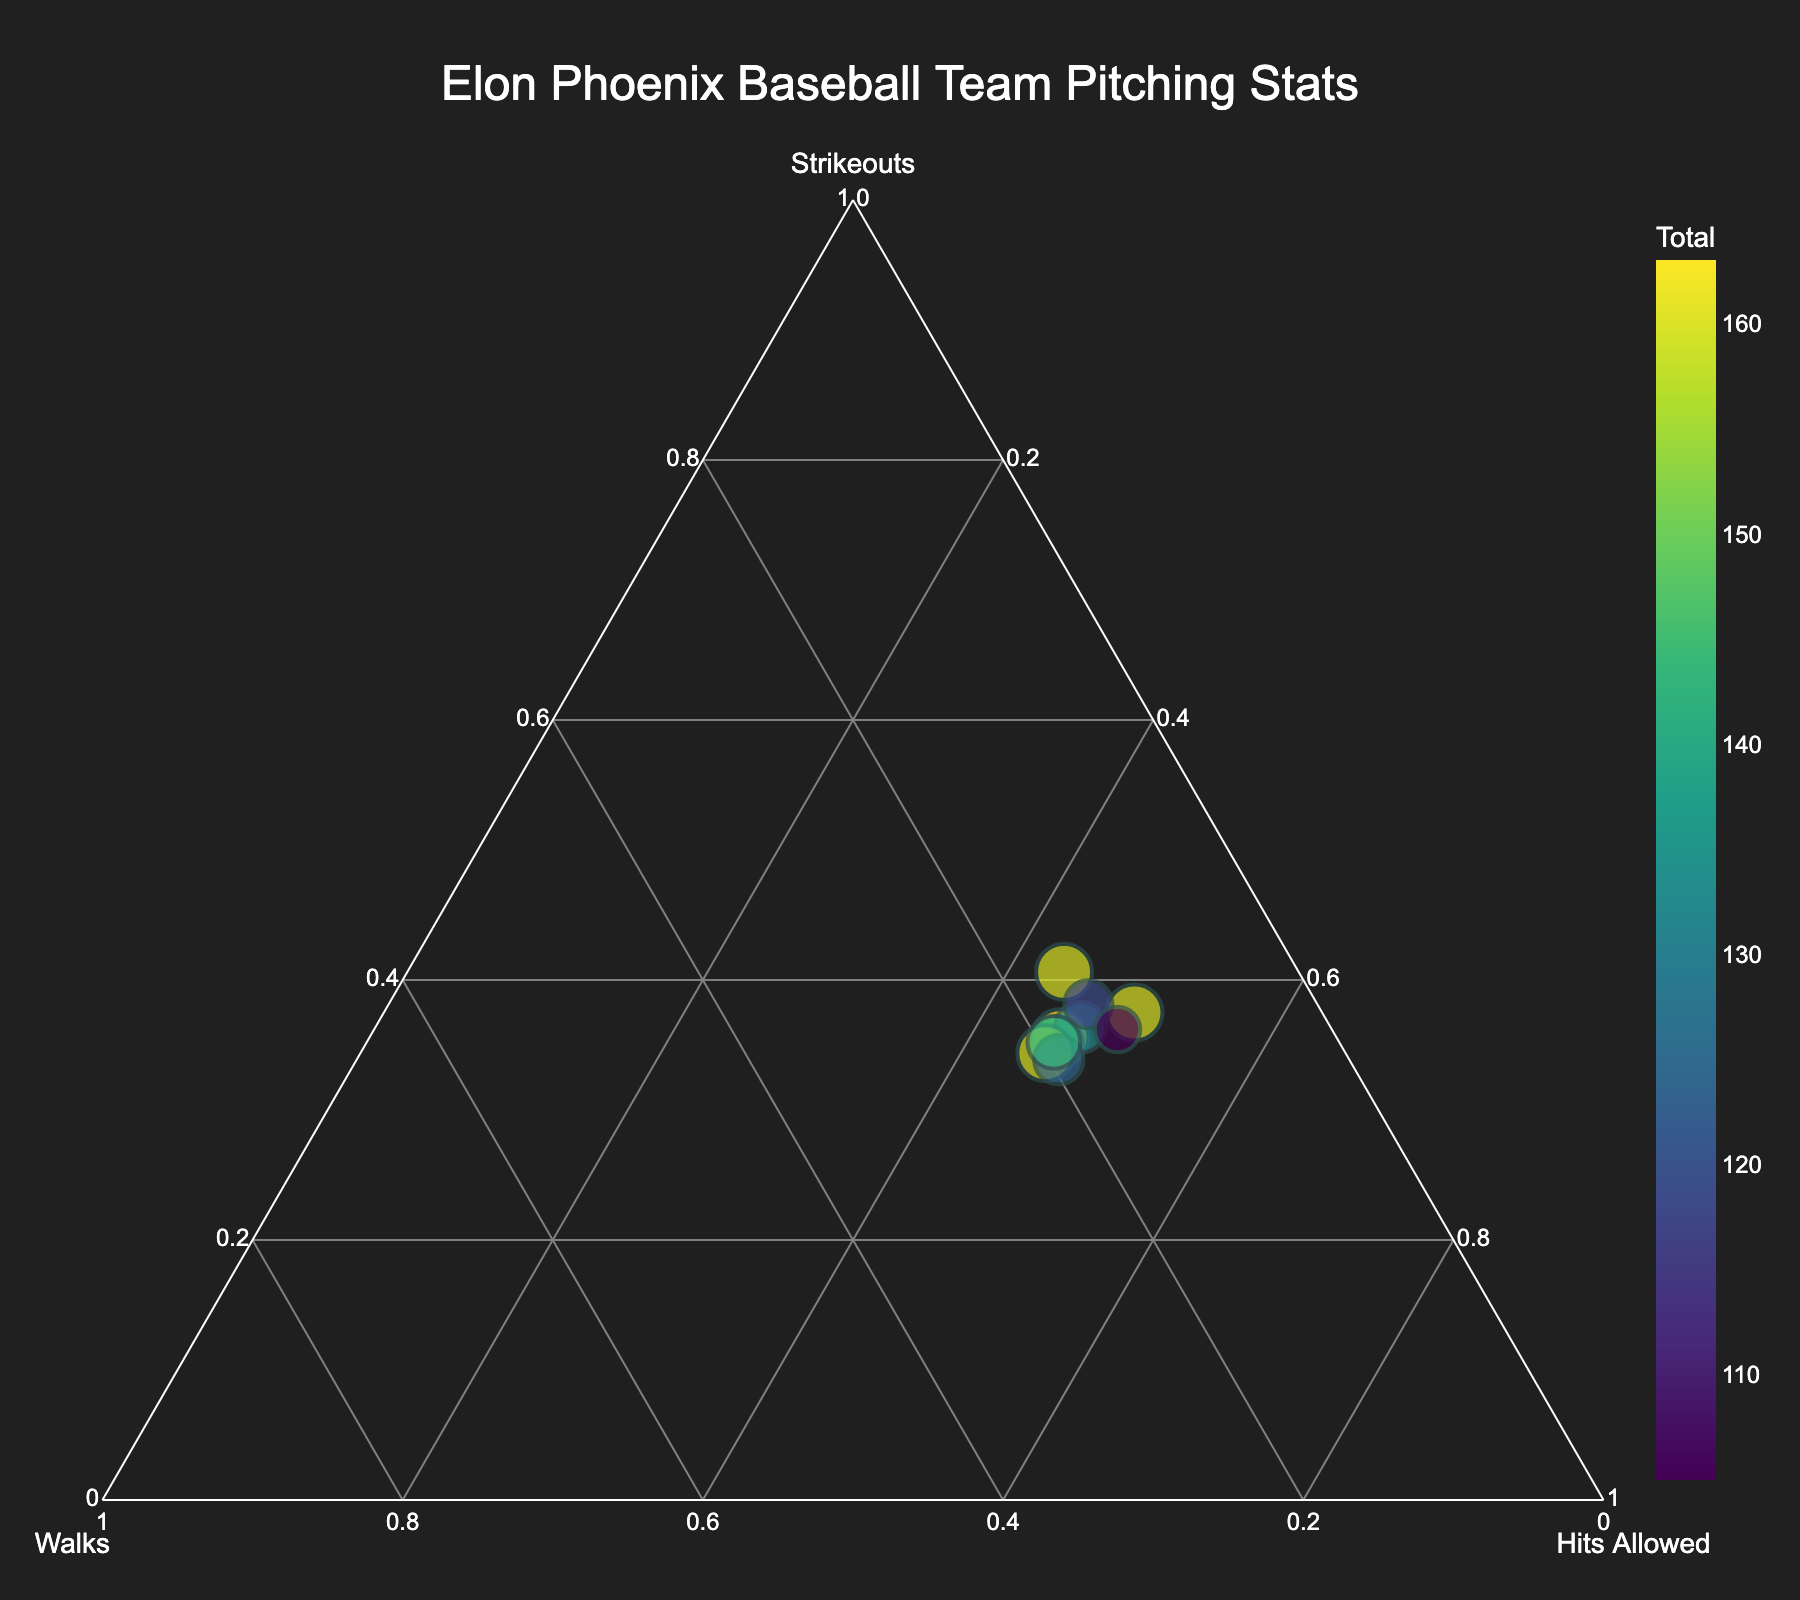What is the title of the ternary plot? The title can be found at the top of the plot.
Answer: Elon Phoenix Baseball Team Pitching Stats Which player has the highest total of Strikeouts, Walks, and Hits Allowed? The size and color intensity of the player's marker can help identify the player with the highest total.
Answer: Jared Wetherbee Between Trevor Kirk and Daniel Albrittain, who has allowed more hits? Compare their positions along the Hits Allowed axis.
Answer: Trevor Kirk Which player is closest to having an equal balance of Strikeouts, Walks, and Hits Allowed? Look for the marker closest to the center of the ternary plot.
Answer: Ben Simon Who has the highest percentage of strikeouts out of their total? The player positioned furthest toward the “Strikeouts” vertex.
Answer: Jared Wetherbee What is the range of total pitching stats (Strikeouts + Walks + Hits Allowed) among all players? Identify the minimum and maximum marker sizes and deduce the range based on those sizes. Maximum total is 160 for Brian Edgington, and minimum total is 105 for Daniel Albrittain.
Answer: 105 to 160 Do any two players have identical pitching compositions in the ternary plot? Check for any overlapping markers or extremely close positions.
Answer: No Among Spencer Bauer, Kyle Greenler, and Shea Sprague, who has the highest walks percentage? Examine their positions relative to the “Walks” vertex.
Answer: Shea Sprague What is the sum of strikeouts and walks for Joseph Sprake? Sum his Strikeouts and Walks directly (48 + 22).
Answer: 70 